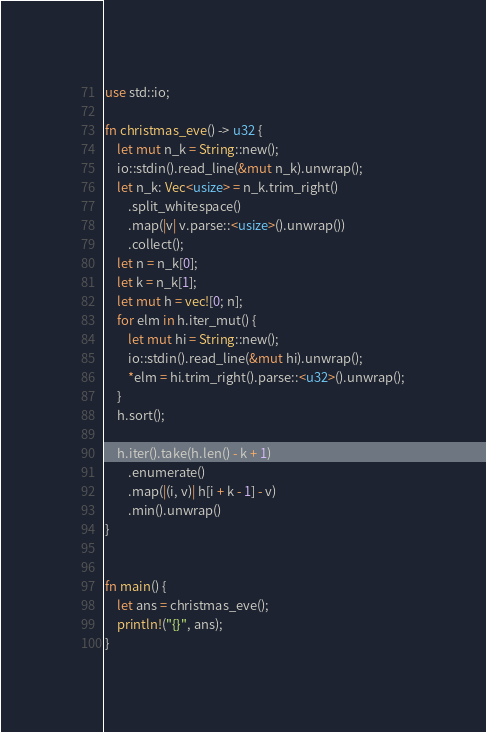<code> <loc_0><loc_0><loc_500><loc_500><_Rust_>use std::io;

fn christmas_eve() -> u32 {
    let mut n_k = String::new();
    io::stdin().read_line(&mut n_k).unwrap();
    let n_k: Vec<usize> = n_k.trim_right()
        .split_whitespace()
        .map(|v| v.parse::<usize>().unwrap())
        .collect();
    let n = n_k[0];
    let k = n_k[1];
    let mut h = vec![0; n];
    for elm in h.iter_mut() {
        let mut hi = String::new();
        io::stdin().read_line(&mut hi).unwrap();
        *elm = hi.trim_right().parse::<u32>().unwrap();
    }
    h.sort();

    h.iter().take(h.len() - k + 1)
        .enumerate()
        .map(|(i, v)| h[i + k - 1] - v)
        .min().unwrap()
}


fn main() {
    let ans = christmas_eve();
    println!("{}", ans);
}</code> 